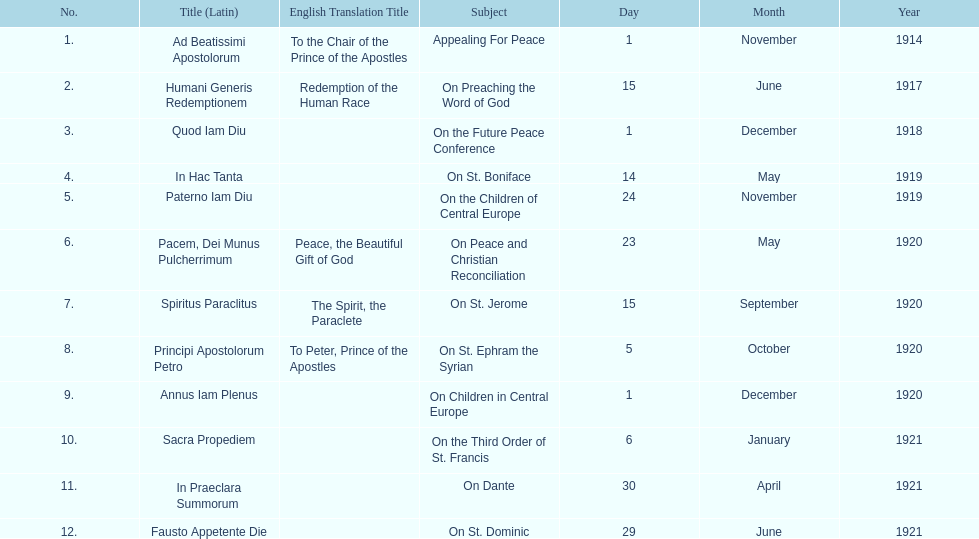What is the subject listed after appealing for peace? On Preaching the Word of God. 